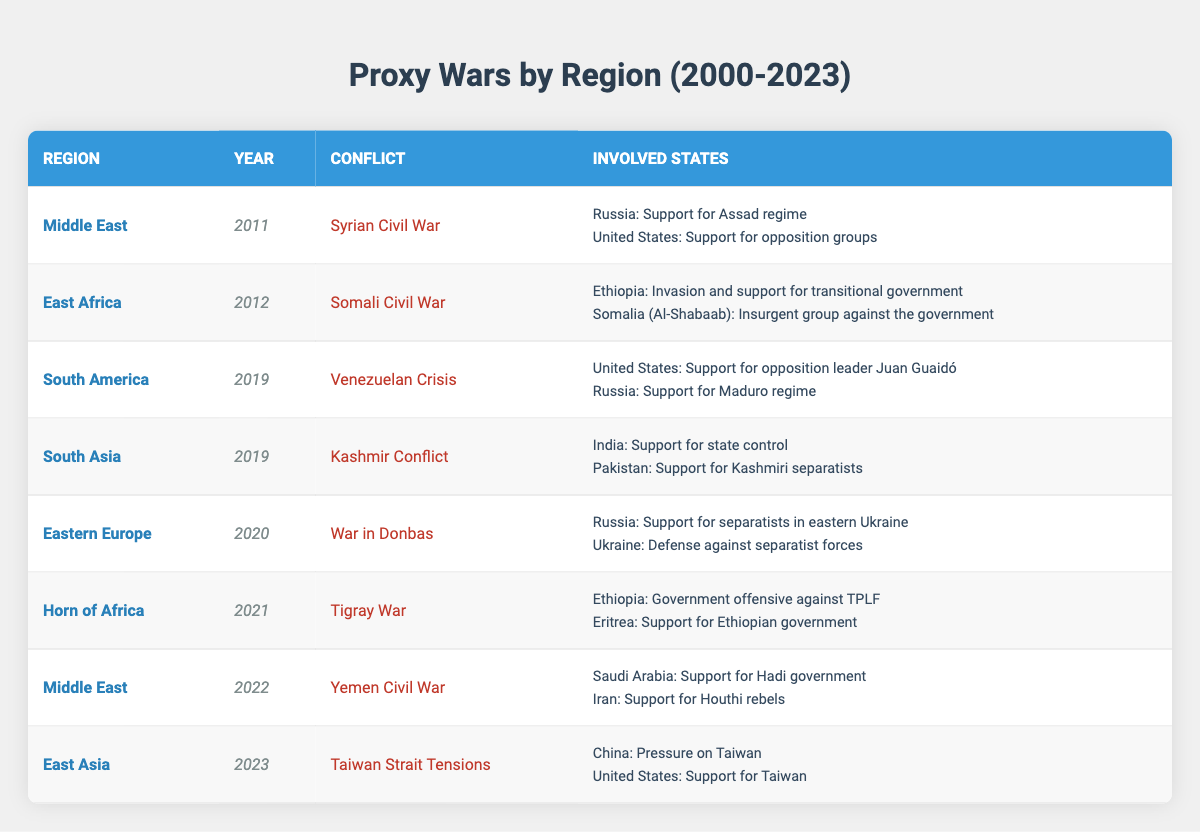What regions experienced proxy wars involving the United States? By scanning the table, I identify the conflicts where the United States is mentioned as an involved state. The regions where these conflicts occur are the Middle East (Syrian Civil War), South America (Venezuelan Crisis), and East Asia (Taiwan Strait Tensions).
Answer: Middle East, South America, East Asia How many different conflicts are listed in the table? The table contains seven rows, each representing a unique conflict from various regions. By counting each row, I can conclude there are seven distinct conflicts: Syrian Civil War, Somali Civil War, Venezuelan Crisis, Kashmir Conflict, War in Donbas, Tigray War, Yemen Civil War, and Taiwan Strait Tensions.
Answer: 7 Which conflict had the involvement of both Russia and the United States? Examining the table, I find two conflicts involving both Russia and the United States: the Syrian Civil War (2011) and the Venezuelan Crisis (2019). Both rows show these states as participants in opposing roles.
Answer: Syrian Civil War, Venezuelan Crisis What was the year with the highest number of proxy wars in the table? I review the table to find the years mentioned. Each conflict has a designated year, with 2019 featuring two conflicts: the Venezuelan Crisis and the Kashmir Conflict. All others have unique years. This indicates 2019 has the highest proxy war activity.
Answer: 2019 Is it true that all conflicts listed involved at least one country supporting a government? By analyzing each row, I see that each conflict includes at least one state taking on the role of government support or defense. Thus, this assertion checks out against the data in the table.
Answer: Yes What conflict was supported by Eritrea? I examine the table for any mention of Eritrea, which is involved in the Tigray War (2021) supporting the Ethiopian government. Thus, this single conflict indicates Eritrea's involvement.
Answer: Tigray War Count the total number of conflicts in the Middle East category. By filtering for the region "Middle East," I find two conflicts: the Syrian Civil War (2011) and the Yemen Civil War (2022). Therefore, the total count for this region is two.
Answer: 2 Which two regions had conflicts in the year 2019? Reviewing all entries from the table for the year 2019, I identify the Kashmir Conflict in South Asia and the Venezuelan Crisis in South America. These are the two regions with conflicts that year.
Answer: South Asia, South America What was the role of Ethiopia in the Tigray War? By referring to the Tigray War listed in the table, I see that Ethiopia's role was as the government offensive against the TPLF, showing their involvement on the side of the government.
Answer: Government offensive against TPLF 